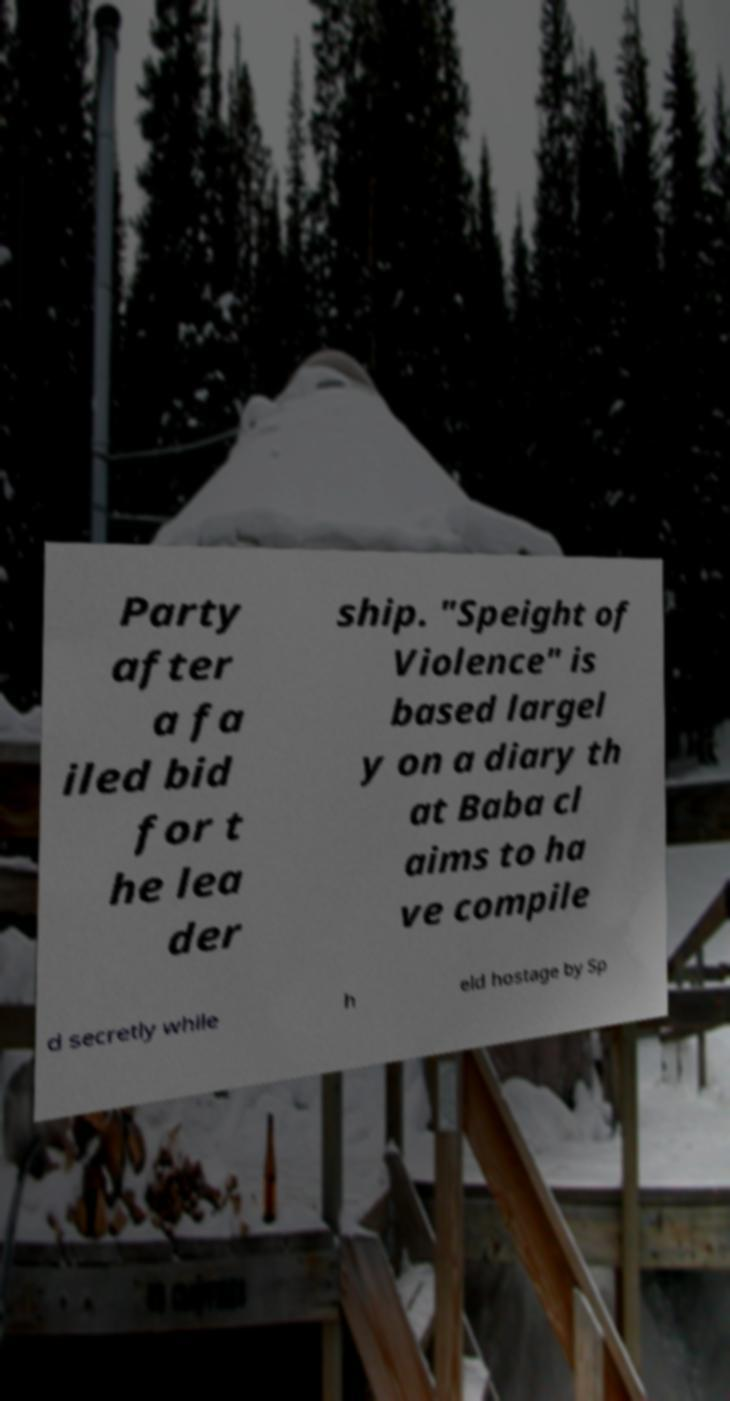What messages or text are displayed in this image? I need them in a readable, typed format. Party after a fa iled bid for t he lea der ship. "Speight of Violence" is based largel y on a diary th at Baba cl aims to ha ve compile d secretly while h eld hostage by Sp 